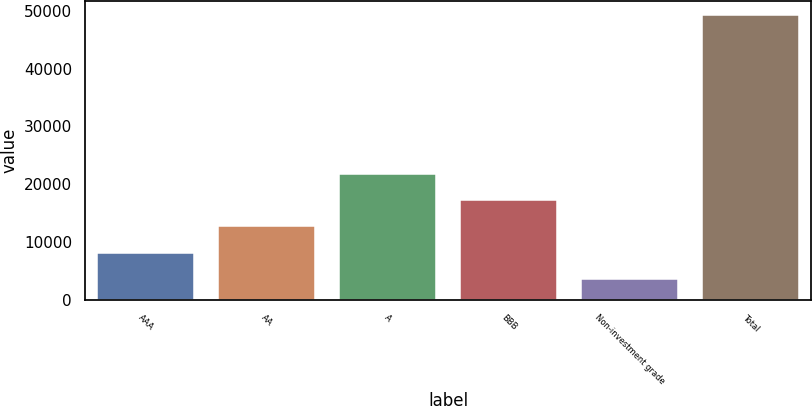<chart> <loc_0><loc_0><loc_500><loc_500><bar_chart><fcel>AAA<fcel>AA<fcel>A<fcel>BBB<fcel>Non-investment grade<fcel>Total<nl><fcel>8127.7<fcel>12688.4<fcel>21809.8<fcel>17249.1<fcel>3567<fcel>49174<nl></chart> 